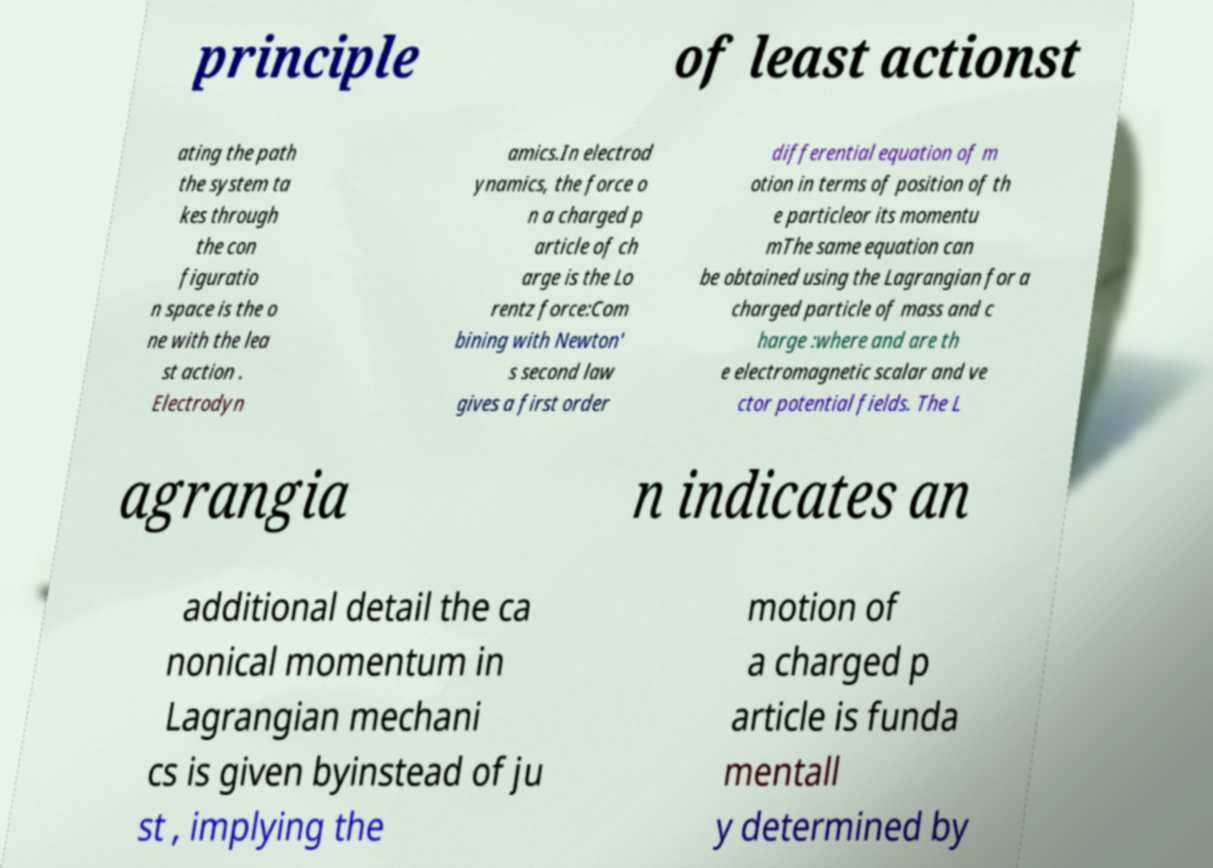I need the written content from this picture converted into text. Can you do that? principle of least actionst ating the path the system ta kes through the con figuratio n space is the o ne with the lea st action . Electrodyn amics.In electrod ynamics, the force o n a charged p article of ch arge is the Lo rentz force:Com bining with Newton' s second law gives a first order differential equation of m otion in terms of position of th e particleor its momentu mThe same equation can be obtained using the Lagrangian for a charged particle of mass and c harge :where and are th e electromagnetic scalar and ve ctor potential fields. The L agrangia n indicates an additional detail the ca nonical momentum in Lagrangian mechani cs is given byinstead of ju st , implying the motion of a charged p article is funda mentall y determined by 